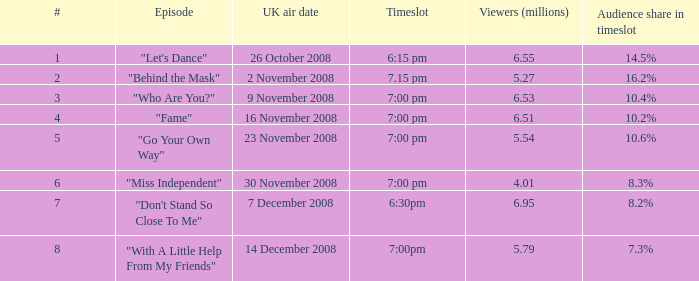For a timeslot with a 10.2% audience share, how many viewers are there in total? 1.0. 